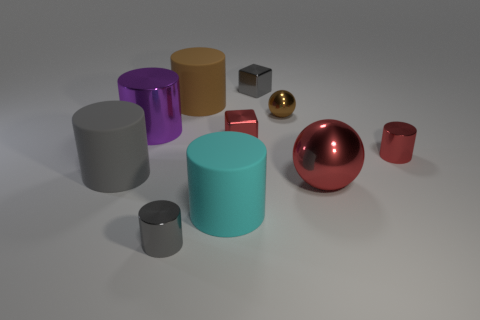Do the gray shiny thing that is in front of the gray matte cylinder and the big purple metal object have the same shape?
Give a very brief answer. Yes. Is there a purple cylinder?
Offer a terse response. Yes. Is there anything else that is the same shape as the purple shiny thing?
Ensure brevity in your answer.  Yes. Is the number of tiny gray shiny things that are behind the cyan cylinder greater than the number of metallic blocks?
Provide a succinct answer. No. Are there any large purple metal objects in front of the large purple thing?
Your response must be concise. No. Do the red sphere and the brown metal ball have the same size?
Provide a succinct answer. No. What is the size of the cyan rubber thing that is the same shape as the large gray object?
Provide a short and direct response. Large. Is there anything else that is the same size as the purple metal object?
Make the answer very short. Yes. What material is the tiny thing left of the small red thing that is on the left side of the red metal cylinder made of?
Ensure brevity in your answer.  Metal. Is the big gray object the same shape as the large red object?
Provide a succinct answer. No. 